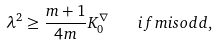<formula> <loc_0><loc_0><loc_500><loc_500>\lambda ^ { 2 } \geq \frac { m + 1 } { 4 m } K _ { 0 } ^ { \nabla } \quad i f m i s o d d ,</formula> 